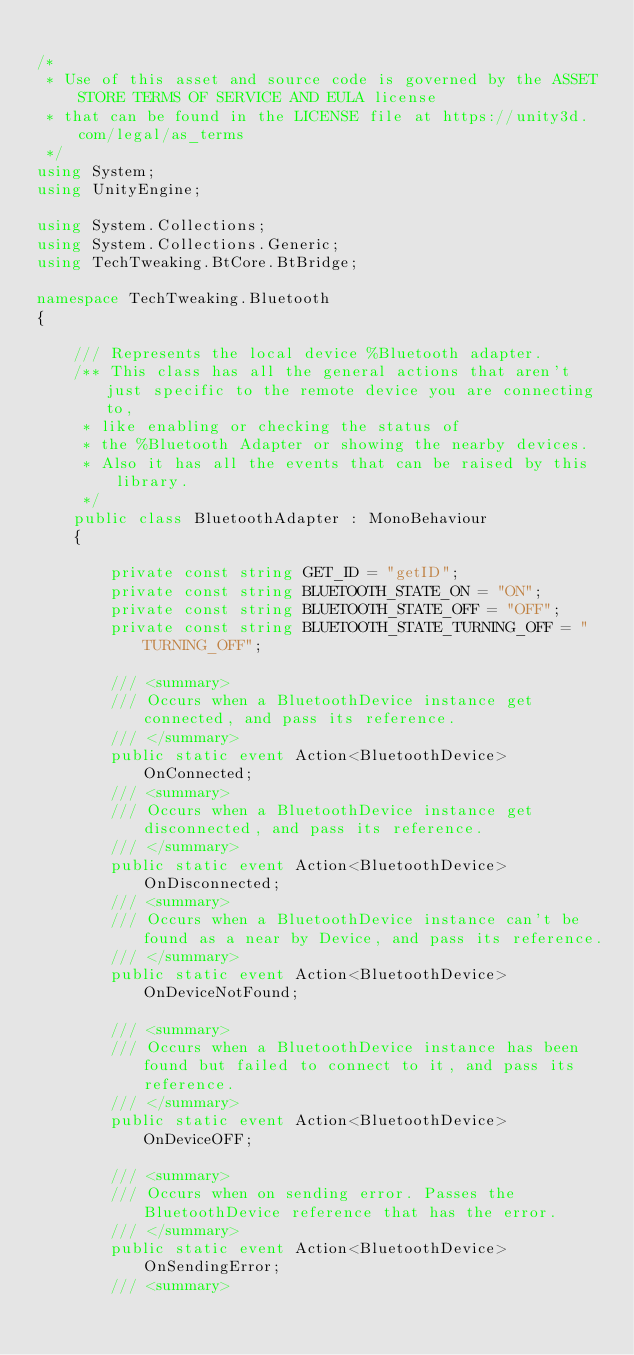Convert code to text. <code><loc_0><loc_0><loc_500><loc_500><_C#_>
/*
 * Use of this asset and source code is governed by the ASSET STORE TERMS OF SERVICE AND EULA license
 * that can be found in the LICENSE file at https://unity3d.com/legal/as_terms
 */
using System;
using UnityEngine;

using System.Collections;
using System.Collections.Generic;
using TechTweaking.BtCore.BtBridge;

namespace TechTweaking.Bluetooth
{

	/// Represents the local device %Bluetooth adapter.
	/** This class has all the general actions that aren't just specific to the remote device you are connecting to,
	 * like enabling or checking the status of
	 * the %Bluetooth Adapter or showing the nearby devices.
	 * Also it has all the events that can be raised by this library.
	 */
	public class BluetoothAdapter : MonoBehaviour
	{

		private const string GET_ID = "getID";
		private const string BLUETOOTH_STATE_ON = "ON";
		private const string BLUETOOTH_STATE_OFF = "OFF";
		private const string BLUETOOTH_STATE_TURNING_OFF = "TURNING_OFF";

		/// <summary>
		/// Occurs when a BluetoothDevice instance get connected, and pass its reference.
		/// </summary>
		public static event Action<BluetoothDevice> OnConnected; 
		/// <summary>
		/// Occurs when a BluetoothDevice instance get disconnected, and pass its reference.
		/// </summary>
		public static event Action<BluetoothDevice> OnDisconnected;
		/// <summary>
		/// Occurs when a BluetoothDevice instance can't be found as a near by Device, and pass its reference.
		/// </summary>
		public static event Action<BluetoothDevice> OnDeviceNotFound;

		/// <summary>
		/// Occurs when a BluetoothDevice instance has been found but failed to connect to it, and pass its reference.
		/// </summary>
		public static event Action<BluetoothDevice> OnDeviceOFF;
	
		/// <summary>
		/// Occurs when on sending error. Passes the BluetoothDevice reference that has the error.
		/// </summary>
		public static event Action<BluetoothDevice> OnSendingError;
		/// <summary></code> 